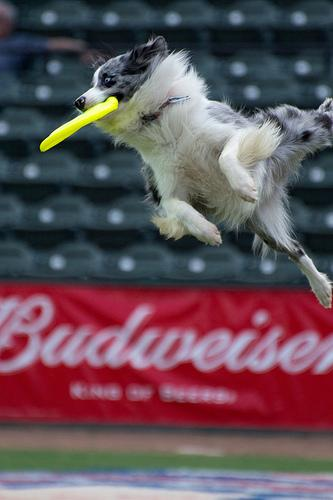Provide a brief overview of the main action happening in the image. A jumping dog is in the process of catching a yellow frisbee in mid-air while a solitary person watches the exhibition from the stands. How would you describe the image's sentiment or mood? The image has an energetic and lively mood, with the spectacle of the dog catching the frisbee in mid-air. Analyze the interaction between the dog and the frisbee in the image. The dog is jumping mid-air to catch the yellow frisbee with its mouth, showing an intense focus and athletic ability. From the perspective of the solitary person watching the exhibition, narrate what they might be thinking or feeling. The person might be thinking about the remarkable skill and agility of the dog as it leaps into the air to catch the frisbee and feeling a sense of admiration or excitement. Identify the color and one specific feature of the dog in the image. The dog is black and white, and it has a distinct blue eye. Count the number of banner parts in the image and mention one of their colors. There are 11 banner parts, and one of them has a red color. Describe the state of the arena and seats in the image. The arena seats are mostly empty, with only one solitary person watching the exhibition. What is the prominent advertising sign in the image and what color is it? There is a red Budweiser beer advertisement sign prominently displayed in the image. What is the total number of objects related to 'ground' and 'grass' in the image? There are 7 objects related to ground and 2 objects related to grass, making a total of 9 objects. Evaluate the image quality and mention one specific element that is out of focus or blurry. The image quality is decent but not perfect, as there is an out-of-focus green patch on the field and a blurry seat number identifier. 